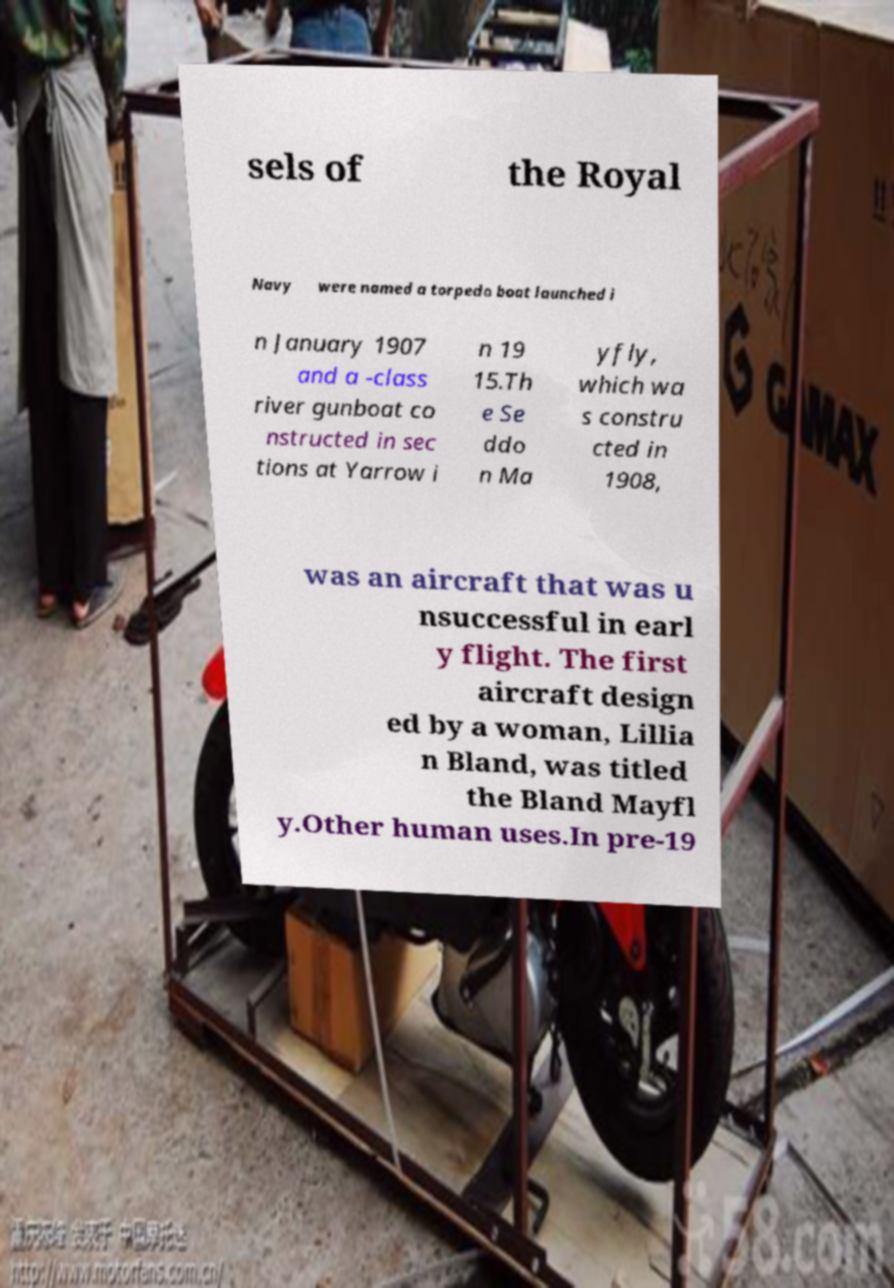Could you extract and type out the text from this image? sels of the Royal Navy were named a torpedo boat launched i n January 1907 and a -class river gunboat co nstructed in sec tions at Yarrow i n 19 15.Th e Se ddo n Ma yfly, which wa s constru cted in 1908, was an aircraft that was u nsuccessful in earl y flight. The first aircraft design ed by a woman, Lillia n Bland, was titled the Bland Mayfl y.Other human uses.In pre-19 